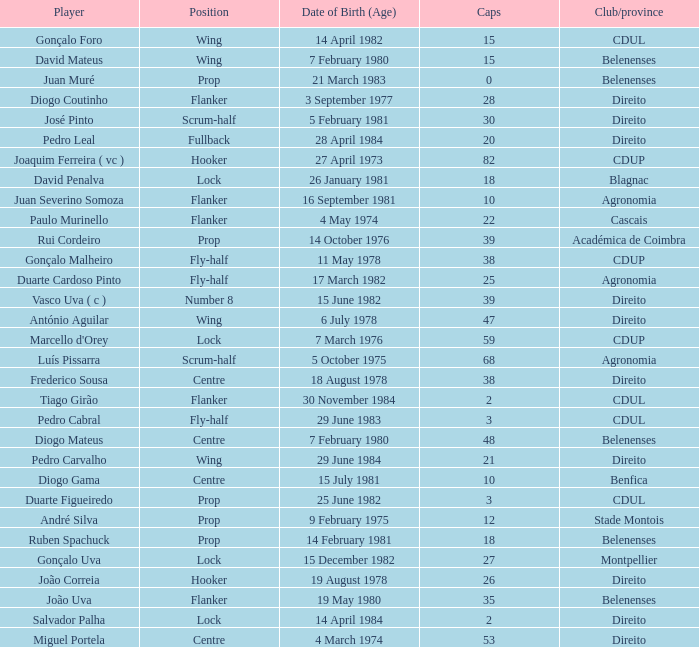How many caps have a Position of prop, and a Player of rui cordeiro? 1.0. 